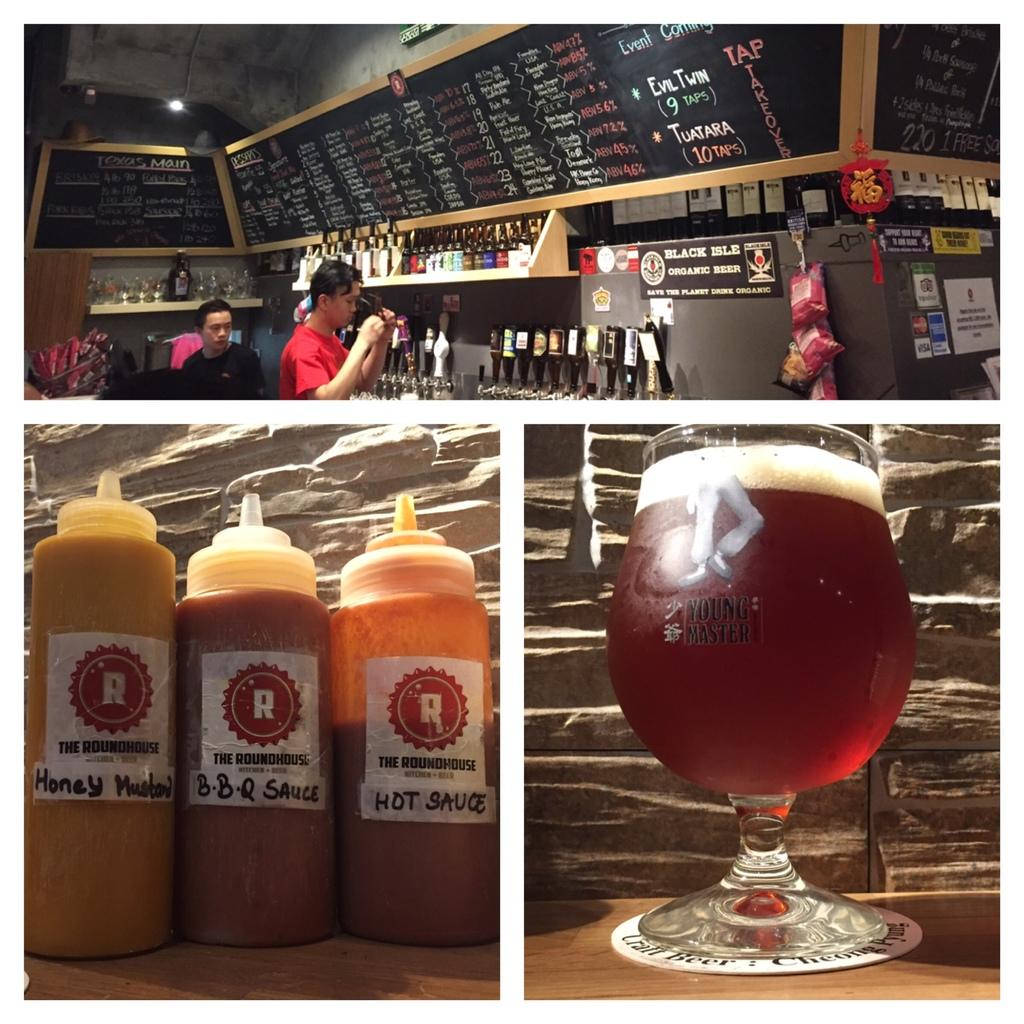<image>
Present a compact description of the photo's key features. the word roundhouse is on a bottle of liquid 